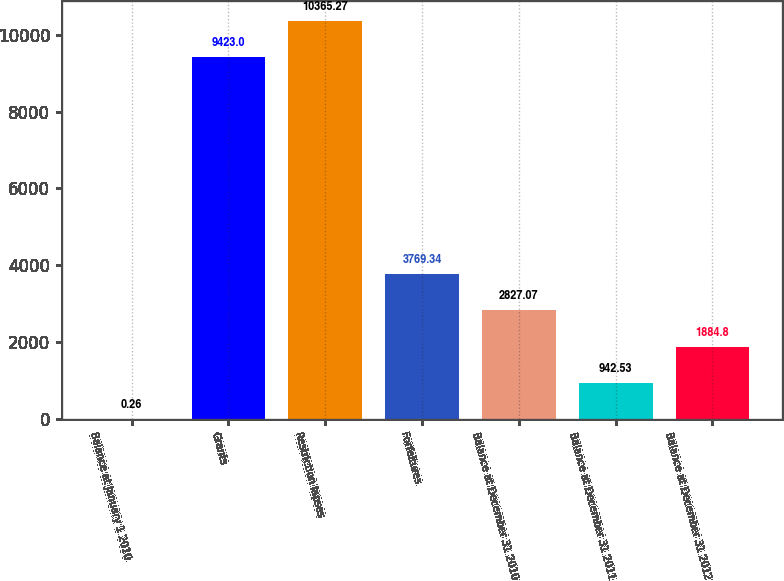Convert chart. <chart><loc_0><loc_0><loc_500><loc_500><bar_chart><fcel>Balance at January 1 2010<fcel>Grants<fcel>Restriction lapses<fcel>Forfeitures<fcel>Balance at December 31 2010<fcel>Balance at December 31 2011<fcel>Balance at December 31 2012<nl><fcel>0.26<fcel>9423<fcel>10365.3<fcel>3769.34<fcel>2827.07<fcel>942.53<fcel>1884.8<nl></chart> 